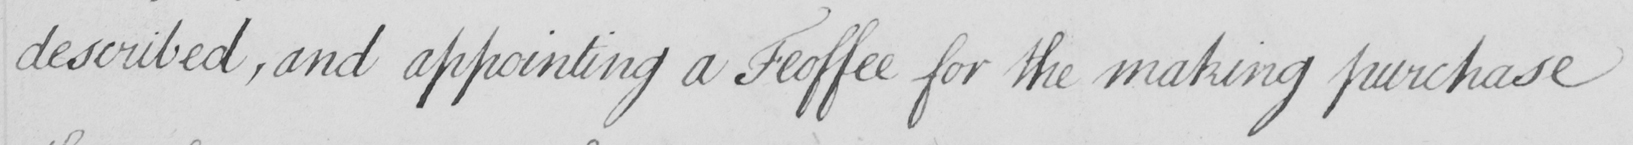What text is written in this handwritten line? described , and appointing a Feoffee for the making purchase 